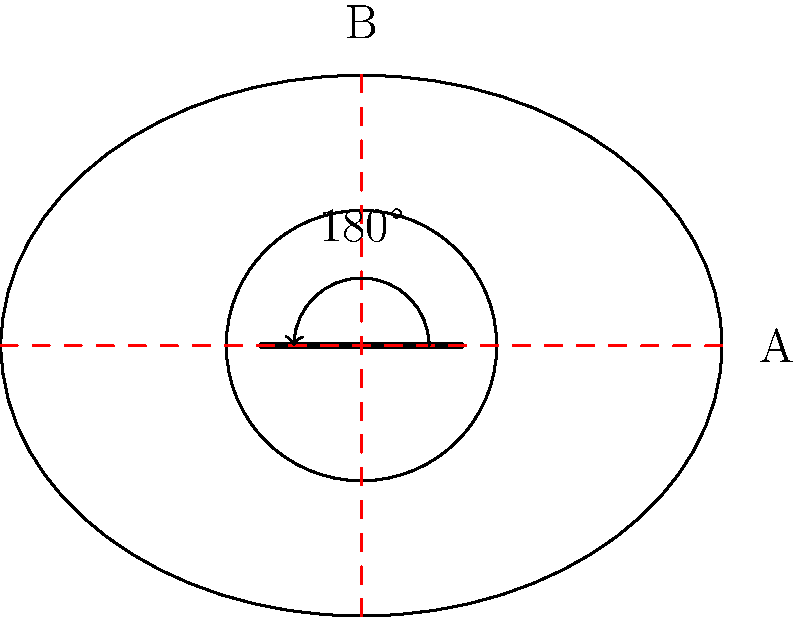In the diagram of a cricket field layout, how many lines of symmetry are there, and what type of rotational symmetry does the field possess? Describe the symmetry operations that leave the field invariant. To analyze the symmetry of the cricket field layout, let's follow these steps:

1. Lines of symmetry:
   a) Vertical line (B): The field is symmetric when folded along the vertical axis.
   b) Horizontal line (A): The field is also symmetric when folded along the horizontal axis.

   Therefore, there are 2 lines of symmetry.

2. Rotational symmetry:
   The field remains unchanged when rotated 180° around its center point. This is known as 2-fold rotational symmetry or order-2 rotational symmetry.

3. Symmetry operations that leave the field invariant:
   a) Identity: No change (trivial operation)
   b) 180° rotation around the center
   c) Reflection across the vertical axis (B)
   d) Reflection across the horizontal axis (A)

These four operations form the symmetry group of the cricket field layout, which is isomorphic to the Klein four-group ($$V_4$$) or the dihedral group $$D_2$$.

The symmetry group can be represented mathematically as:
$$G = \{e, r, s_v, s_h\}$$
Where:
- $$e$$ is the identity operation
- $$r$$ is the 180° rotation
- $$s_v$$ is the reflection across the vertical axis
- $$s_h$$ is the reflection across the horizontal axis

This group has the following properties:
1. Closure: Applying any two operations in succession results in another operation within the group.
2. Associativity: $$(a * b) * c = a * (b * c)$$ for all operations $$a$$, $$b$$, and $$c$$ in the group.
3. Identity: The identity operation $$e$$ leaves the field unchanged.
4. Inverse: Each operation has an inverse that undoes its effect (in this case, each operation is its own inverse).
Answer: 2 lines of symmetry; 2-fold rotational symmetry; Group: $$\{e, r, s_v, s_h\}$$ isomorphic to $$V_4$$ or $$D_2$$. 